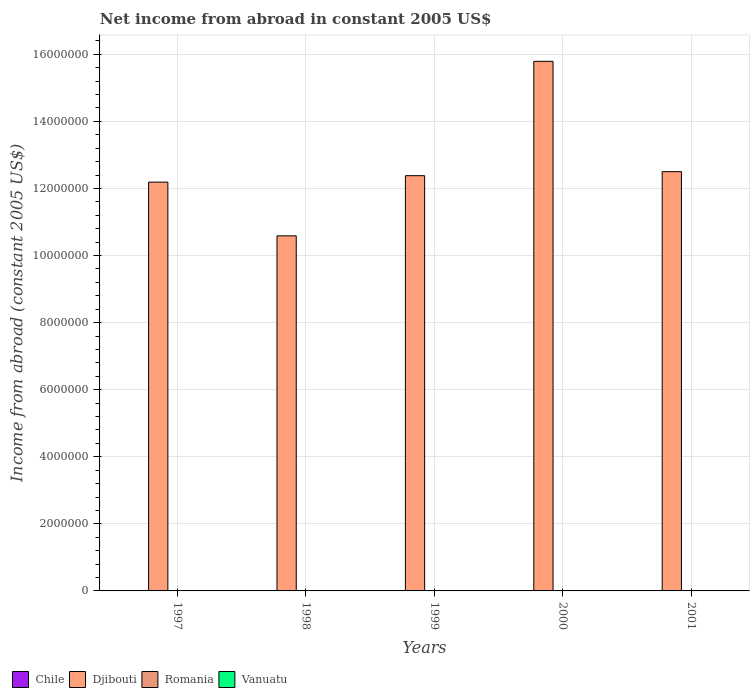How many different coloured bars are there?
Ensure brevity in your answer.  1. Are the number of bars per tick equal to the number of legend labels?
Offer a very short reply. No. Across all years, what is the maximum net income from abroad in Djibouti?
Your answer should be very brief. 1.58e+07. What is the difference between the net income from abroad in Djibouti in 1998 and that in 2000?
Give a very brief answer. -5.20e+06. What is the difference between the net income from abroad in Romania in 1997 and the net income from abroad in Vanuatu in 2001?
Ensure brevity in your answer.  0. What is the average net income from abroad in Vanuatu per year?
Provide a short and direct response. 0. In how many years, is the net income from abroad in Djibouti greater than 800000 US$?
Your answer should be very brief. 5. What is the ratio of the net income from abroad in Djibouti in 1998 to that in 2001?
Provide a short and direct response. 0.85. Is the net income from abroad in Djibouti in 1999 less than that in 2001?
Offer a very short reply. Yes. What is the difference between the highest and the second highest net income from abroad in Djibouti?
Your response must be concise. 3.29e+06. What is the difference between the highest and the lowest net income from abroad in Djibouti?
Your response must be concise. 5.20e+06. Is the sum of the net income from abroad in Djibouti in 1998 and 1999 greater than the maximum net income from abroad in Vanuatu across all years?
Offer a terse response. Yes. Is it the case that in every year, the sum of the net income from abroad in Vanuatu and net income from abroad in Chile is greater than the sum of net income from abroad in Djibouti and net income from abroad in Romania?
Provide a short and direct response. No. How many years are there in the graph?
Provide a succinct answer. 5. What is the difference between two consecutive major ticks on the Y-axis?
Give a very brief answer. 2.00e+06. Are the values on the major ticks of Y-axis written in scientific E-notation?
Make the answer very short. No. Does the graph contain grids?
Your answer should be very brief. Yes. Where does the legend appear in the graph?
Your answer should be compact. Bottom left. What is the title of the graph?
Ensure brevity in your answer.  Net income from abroad in constant 2005 US$. Does "New Zealand" appear as one of the legend labels in the graph?
Your answer should be very brief. No. What is the label or title of the Y-axis?
Give a very brief answer. Income from abroad (constant 2005 US$). What is the Income from abroad (constant 2005 US$) of Djibouti in 1997?
Keep it short and to the point. 1.22e+07. What is the Income from abroad (constant 2005 US$) in Romania in 1997?
Offer a very short reply. 0. What is the Income from abroad (constant 2005 US$) of Vanuatu in 1997?
Your answer should be very brief. 0. What is the Income from abroad (constant 2005 US$) of Djibouti in 1998?
Ensure brevity in your answer.  1.06e+07. What is the Income from abroad (constant 2005 US$) of Chile in 1999?
Make the answer very short. 0. What is the Income from abroad (constant 2005 US$) in Djibouti in 1999?
Keep it short and to the point. 1.24e+07. What is the Income from abroad (constant 2005 US$) of Vanuatu in 1999?
Give a very brief answer. 0. What is the Income from abroad (constant 2005 US$) of Djibouti in 2000?
Keep it short and to the point. 1.58e+07. What is the Income from abroad (constant 2005 US$) in Romania in 2000?
Your response must be concise. 0. What is the Income from abroad (constant 2005 US$) of Chile in 2001?
Provide a short and direct response. 0. What is the Income from abroad (constant 2005 US$) of Djibouti in 2001?
Provide a succinct answer. 1.25e+07. What is the Income from abroad (constant 2005 US$) in Romania in 2001?
Give a very brief answer. 0. What is the Income from abroad (constant 2005 US$) in Vanuatu in 2001?
Offer a terse response. 0. Across all years, what is the maximum Income from abroad (constant 2005 US$) in Djibouti?
Ensure brevity in your answer.  1.58e+07. Across all years, what is the minimum Income from abroad (constant 2005 US$) in Djibouti?
Ensure brevity in your answer.  1.06e+07. What is the total Income from abroad (constant 2005 US$) of Chile in the graph?
Provide a short and direct response. 0. What is the total Income from abroad (constant 2005 US$) in Djibouti in the graph?
Provide a succinct answer. 6.34e+07. What is the total Income from abroad (constant 2005 US$) in Romania in the graph?
Keep it short and to the point. 0. What is the total Income from abroad (constant 2005 US$) in Vanuatu in the graph?
Keep it short and to the point. 0. What is the difference between the Income from abroad (constant 2005 US$) in Djibouti in 1997 and that in 1998?
Offer a terse response. 1.60e+06. What is the difference between the Income from abroad (constant 2005 US$) in Djibouti in 1997 and that in 1999?
Offer a very short reply. -1.92e+05. What is the difference between the Income from abroad (constant 2005 US$) of Djibouti in 1997 and that in 2000?
Give a very brief answer. -3.60e+06. What is the difference between the Income from abroad (constant 2005 US$) of Djibouti in 1997 and that in 2001?
Give a very brief answer. -3.12e+05. What is the difference between the Income from abroad (constant 2005 US$) of Djibouti in 1998 and that in 1999?
Make the answer very short. -1.79e+06. What is the difference between the Income from abroad (constant 2005 US$) in Djibouti in 1998 and that in 2000?
Provide a succinct answer. -5.20e+06. What is the difference between the Income from abroad (constant 2005 US$) of Djibouti in 1998 and that in 2001?
Offer a very short reply. -1.91e+06. What is the difference between the Income from abroad (constant 2005 US$) in Djibouti in 1999 and that in 2000?
Offer a very short reply. -3.41e+06. What is the difference between the Income from abroad (constant 2005 US$) of Djibouti in 1999 and that in 2001?
Offer a very short reply. -1.20e+05. What is the difference between the Income from abroad (constant 2005 US$) of Djibouti in 2000 and that in 2001?
Give a very brief answer. 3.29e+06. What is the average Income from abroad (constant 2005 US$) of Chile per year?
Your answer should be very brief. 0. What is the average Income from abroad (constant 2005 US$) of Djibouti per year?
Your answer should be very brief. 1.27e+07. What is the average Income from abroad (constant 2005 US$) of Romania per year?
Keep it short and to the point. 0. What is the average Income from abroad (constant 2005 US$) in Vanuatu per year?
Provide a short and direct response. 0. What is the ratio of the Income from abroad (constant 2005 US$) in Djibouti in 1997 to that in 1998?
Make the answer very short. 1.15. What is the ratio of the Income from abroad (constant 2005 US$) in Djibouti in 1997 to that in 1999?
Offer a terse response. 0.98. What is the ratio of the Income from abroad (constant 2005 US$) in Djibouti in 1997 to that in 2000?
Offer a terse response. 0.77. What is the ratio of the Income from abroad (constant 2005 US$) of Djibouti in 1998 to that in 1999?
Keep it short and to the point. 0.86. What is the ratio of the Income from abroad (constant 2005 US$) in Djibouti in 1998 to that in 2000?
Offer a terse response. 0.67. What is the ratio of the Income from abroad (constant 2005 US$) in Djibouti in 1998 to that in 2001?
Offer a very short reply. 0.85. What is the ratio of the Income from abroad (constant 2005 US$) in Djibouti in 1999 to that in 2000?
Give a very brief answer. 0.78. What is the ratio of the Income from abroad (constant 2005 US$) of Djibouti in 1999 to that in 2001?
Your answer should be compact. 0.99. What is the ratio of the Income from abroad (constant 2005 US$) of Djibouti in 2000 to that in 2001?
Offer a very short reply. 1.26. What is the difference between the highest and the second highest Income from abroad (constant 2005 US$) in Djibouti?
Provide a succinct answer. 3.29e+06. What is the difference between the highest and the lowest Income from abroad (constant 2005 US$) in Djibouti?
Provide a succinct answer. 5.20e+06. 